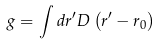<formula> <loc_0><loc_0><loc_500><loc_500>g = \int d r ^ { \prime } D \left ( r ^ { \prime } - r _ { 0 } \right )</formula> 